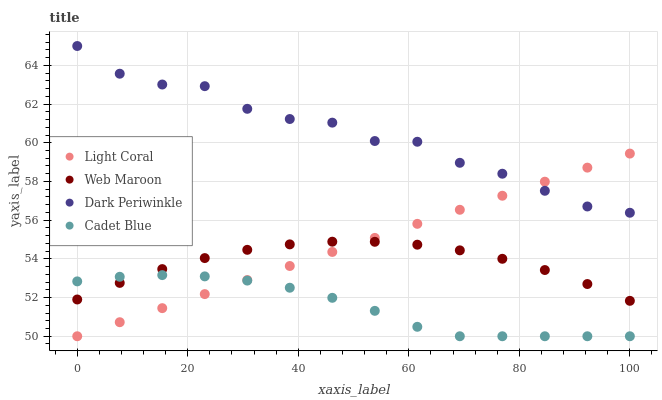Does Cadet Blue have the minimum area under the curve?
Answer yes or no. Yes. Does Dark Periwinkle have the maximum area under the curve?
Answer yes or no. Yes. Does Web Maroon have the minimum area under the curve?
Answer yes or no. No. Does Web Maroon have the maximum area under the curve?
Answer yes or no. No. Is Light Coral the smoothest?
Answer yes or no. Yes. Is Dark Periwinkle the roughest?
Answer yes or no. Yes. Is Cadet Blue the smoothest?
Answer yes or no. No. Is Cadet Blue the roughest?
Answer yes or no. No. Does Light Coral have the lowest value?
Answer yes or no. Yes. Does Web Maroon have the lowest value?
Answer yes or no. No. Does Dark Periwinkle have the highest value?
Answer yes or no. Yes. Does Web Maroon have the highest value?
Answer yes or no. No. Is Cadet Blue less than Dark Periwinkle?
Answer yes or no. Yes. Is Dark Periwinkle greater than Cadet Blue?
Answer yes or no. Yes. Does Cadet Blue intersect Light Coral?
Answer yes or no. Yes. Is Cadet Blue less than Light Coral?
Answer yes or no. No. Is Cadet Blue greater than Light Coral?
Answer yes or no. No. Does Cadet Blue intersect Dark Periwinkle?
Answer yes or no. No. 